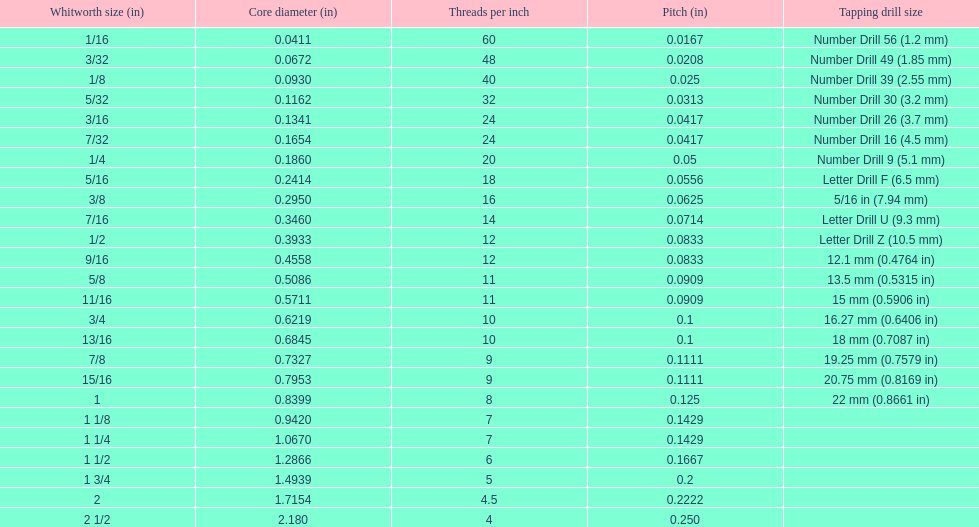What is the central diameter of the final whitworth thread size? 2.180. 